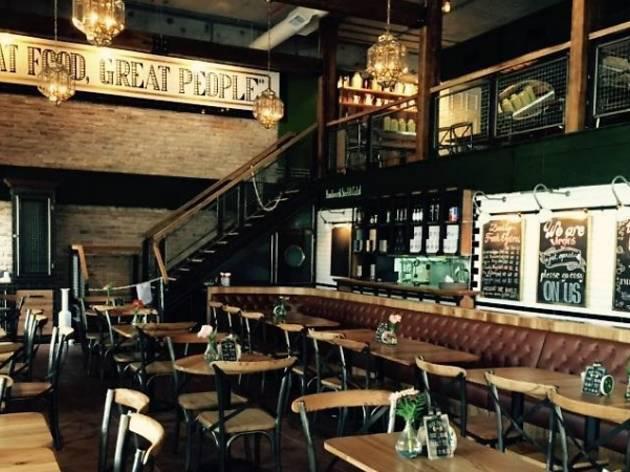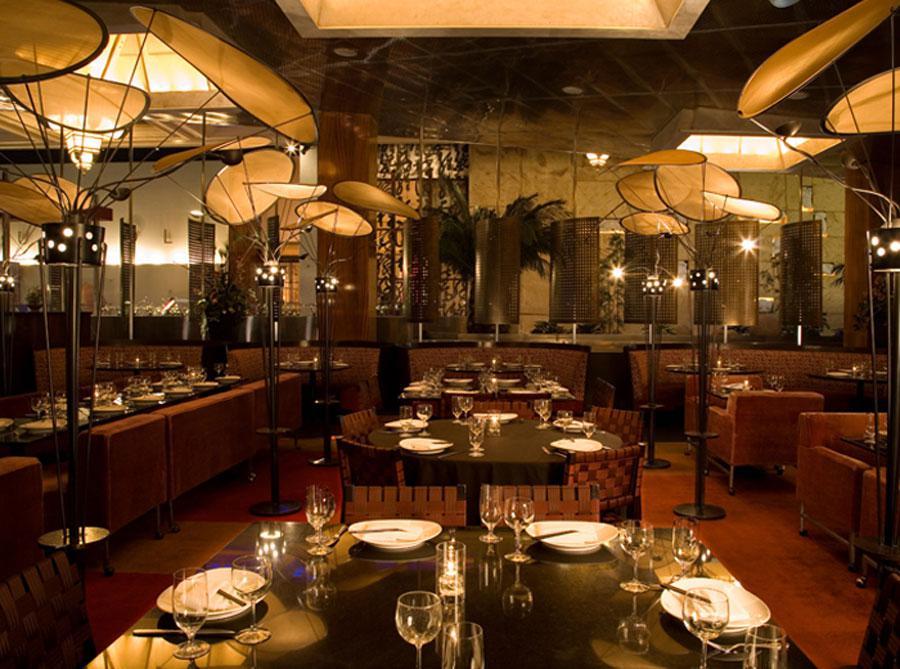The first image is the image on the left, the second image is the image on the right. Given the left and right images, does the statement "There is at least four white cloth tables." hold true? Answer yes or no. No. 